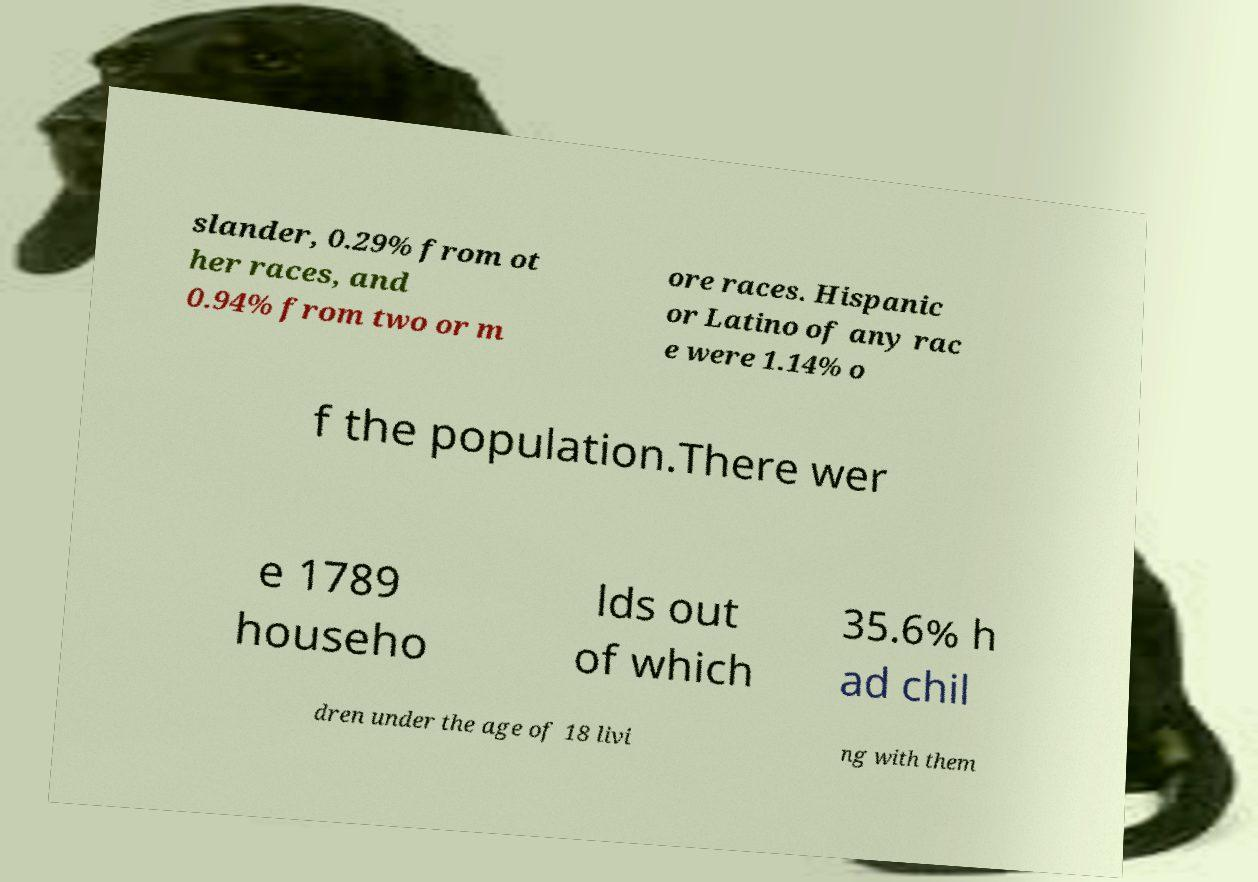Please read and relay the text visible in this image. What does it say? slander, 0.29% from ot her races, and 0.94% from two or m ore races. Hispanic or Latino of any rac e were 1.14% o f the population.There wer e 1789 househo lds out of which 35.6% h ad chil dren under the age of 18 livi ng with them 